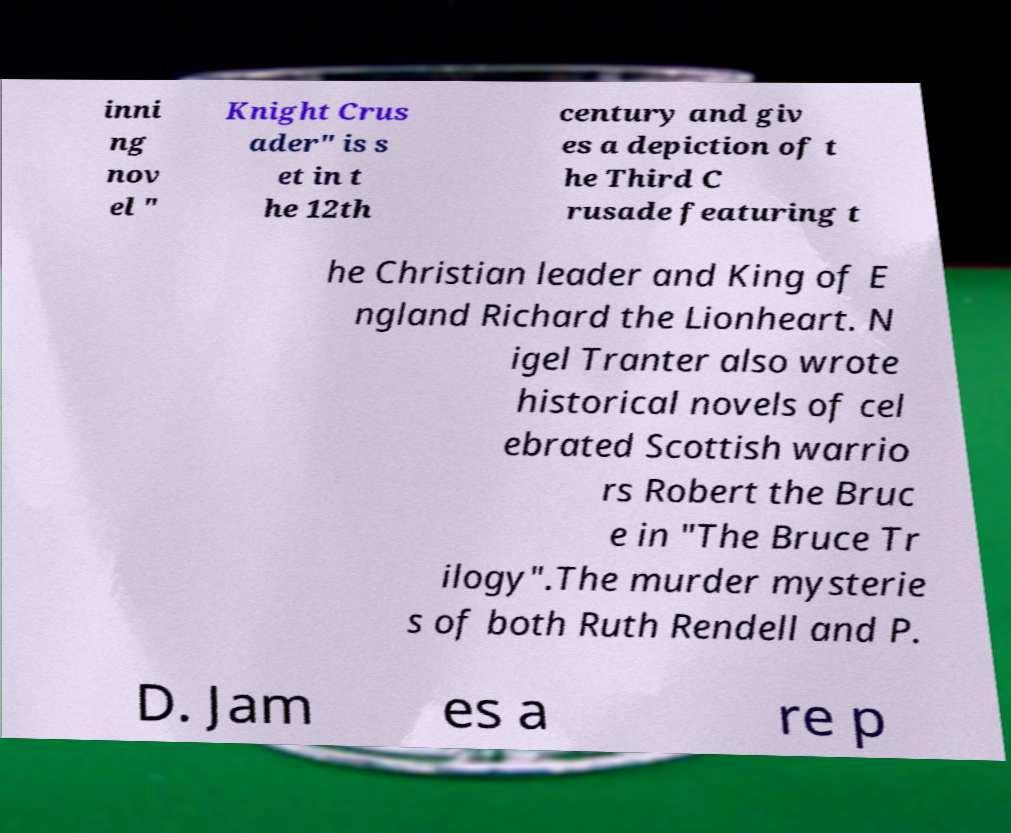Please identify and transcribe the text found in this image. inni ng nov el " Knight Crus ader" is s et in t he 12th century and giv es a depiction of t he Third C rusade featuring t he Christian leader and King of E ngland Richard the Lionheart. N igel Tranter also wrote historical novels of cel ebrated Scottish warrio rs Robert the Bruc e in "The Bruce Tr ilogy".The murder mysterie s of both Ruth Rendell and P. D. Jam es a re p 